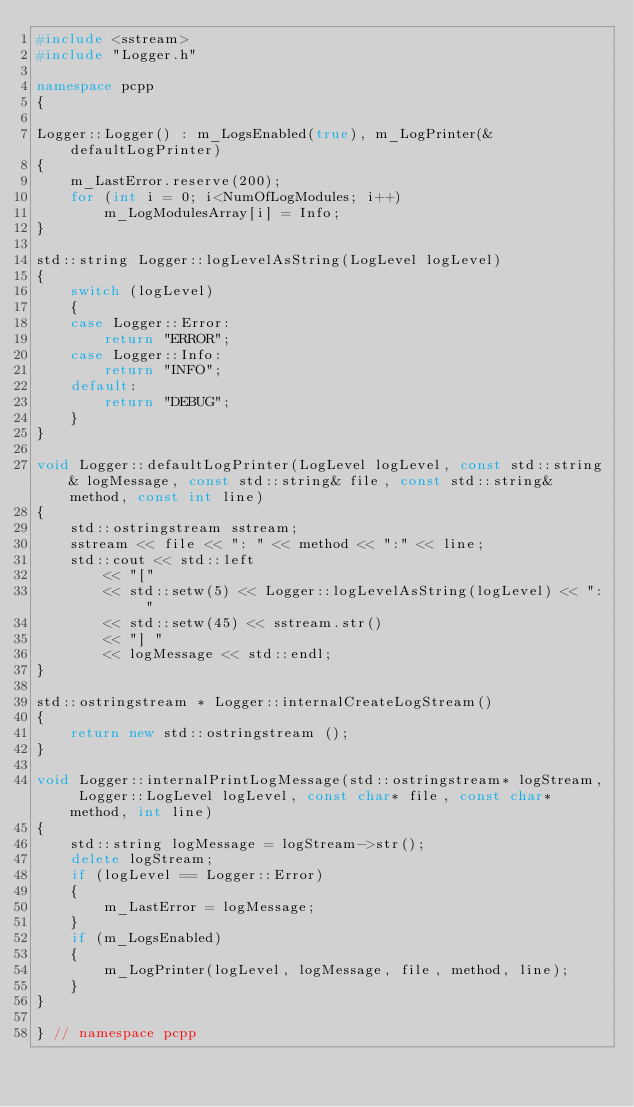<code> <loc_0><loc_0><loc_500><loc_500><_C++_>#include <sstream>
#include "Logger.h"

namespace pcpp
{

Logger::Logger() : m_LogsEnabled(true), m_LogPrinter(&defaultLogPrinter)
{
	m_LastError.reserve(200);
	for (int i = 0; i<NumOfLogModules; i++)
		m_LogModulesArray[i] = Info;
}

std::string Logger::logLevelAsString(LogLevel logLevel)
{
	switch (logLevel)
	{
	case Logger::Error:
		return "ERROR";
	case Logger::Info:
		return "INFO";
	default:
		return "DEBUG";
	}
}

void Logger::defaultLogPrinter(LogLevel logLevel, const std::string& logMessage, const std::string& file, const std::string& method, const int line)
{
	std::ostringstream sstream;
	sstream << file << ": " << method << ":" << line;
	std::cout << std::left
		<< "["
		<< std::setw(5) << Logger::logLevelAsString(logLevel) << ": "
		<< std::setw(45) << sstream.str()
		<< "] "
		<< logMessage << std::endl;
}

std::ostringstream * Logger::internalCreateLogStream()
{
	return new std::ostringstream ();
}

void Logger::internalPrintLogMessage(std::ostringstream* logStream, Logger::LogLevel logLevel, const char* file, const char* method, int line)
{
	std::string logMessage = logStream->str();
	delete logStream;
	if (logLevel == Logger::Error)
	{
		m_LastError = logMessage;
	}
	if (m_LogsEnabled)
	{
		m_LogPrinter(logLevel, logMessage, file, method, line);
	}
}

} // namespace pcpp
</code> 